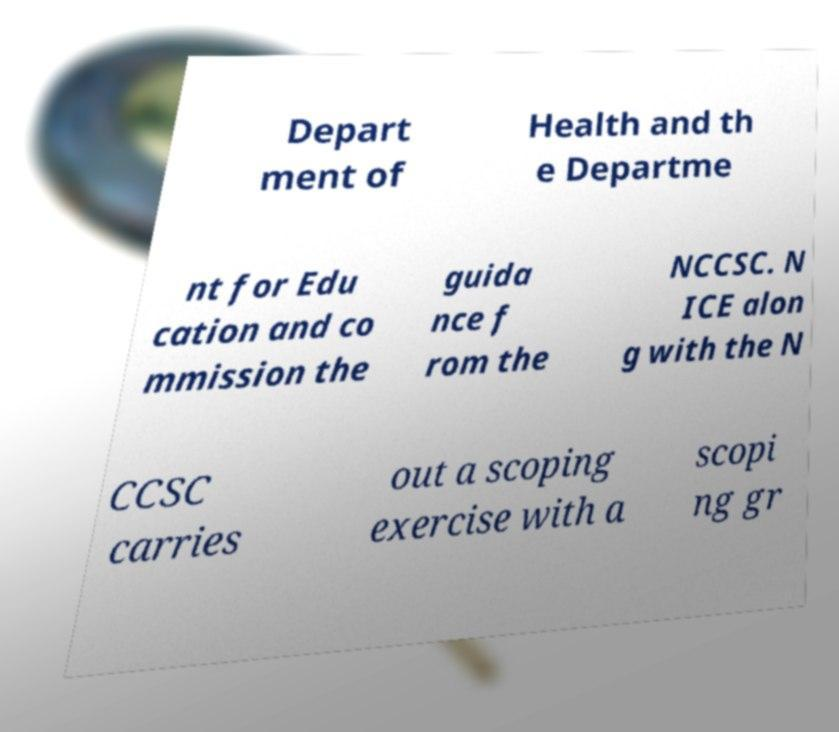There's text embedded in this image that I need extracted. Can you transcribe it verbatim? Depart ment of Health and th e Departme nt for Edu cation and co mmission the guida nce f rom the NCCSC. N ICE alon g with the N CCSC carries out a scoping exercise with a scopi ng gr 